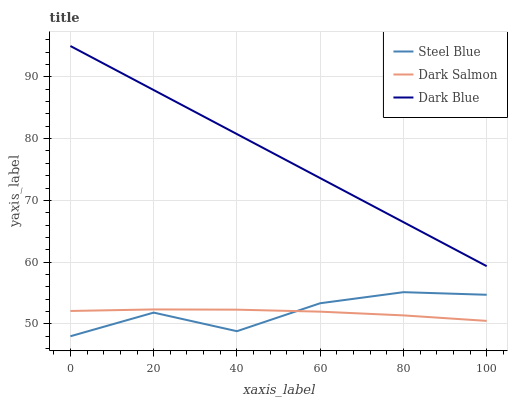Does Dark Salmon have the minimum area under the curve?
Answer yes or no. Yes. Does Dark Blue have the maximum area under the curve?
Answer yes or no. Yes. Does Steel Blue have the minimum area under the curve?
Answer yes or no. No. Does Steel Blue have the maximum area under the curve?
Answer yes or no. No. Is Dark Blue the smoothest?
Answer yes or no. Yes. Is Steel Blue the roughest?
Answer yes or no. Yes. Is Dark Salmon the smoothest?
Answer yes or no. No. Is Dark Salmon the roughest?
Answer yes or no. No. Does Dark Salmon have the lowest value?
Answer yes or no. No. Does Steel Blue have the highest value?
Answer yes or no. No. Is Dark Salmon less than Dark Blue?
Answer yes or no. Yes. Is Dark Blue greater than Steel Blue?
Answer yes or no. Yes. Does Dark Salmon intersect Dark Blue?
Answer yes or no. No. 